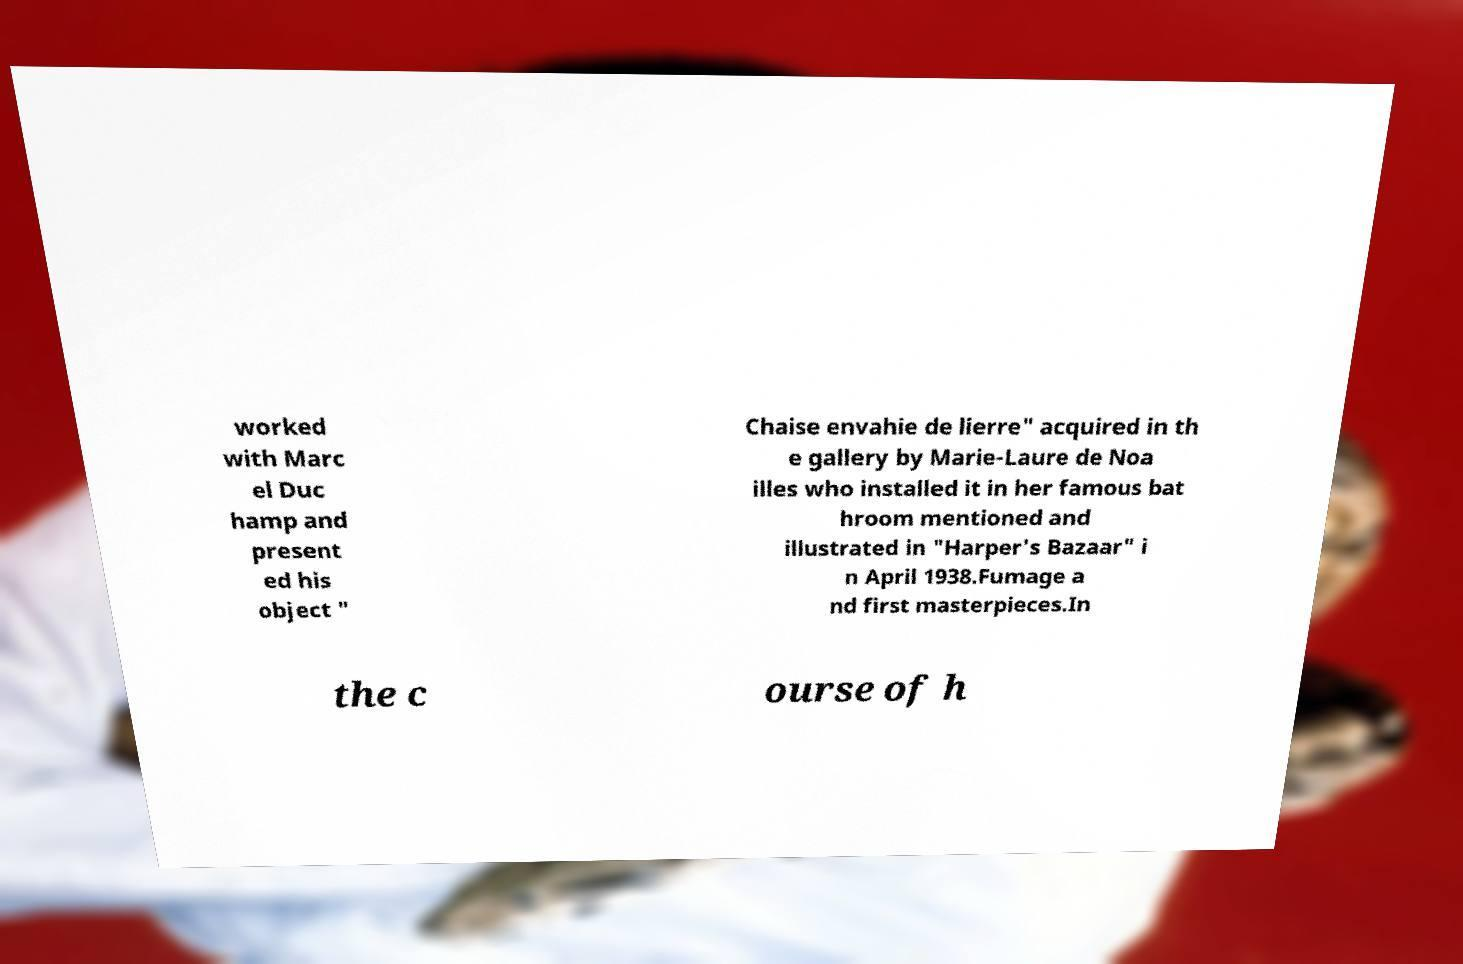Could you assist in decoding the text presented in this image and type it out clearly? worked with Marc el Duc hamp and present ed his object " Chaise envahie de lierre" acquired in th e gallery by Marie-Laure de Noa illes who installed it in her famous bat hroom mentioned and illustrated in "Harper's Bazaar" i n April 1938.Fumage a nd first masterpieces.In the c ourse of h 